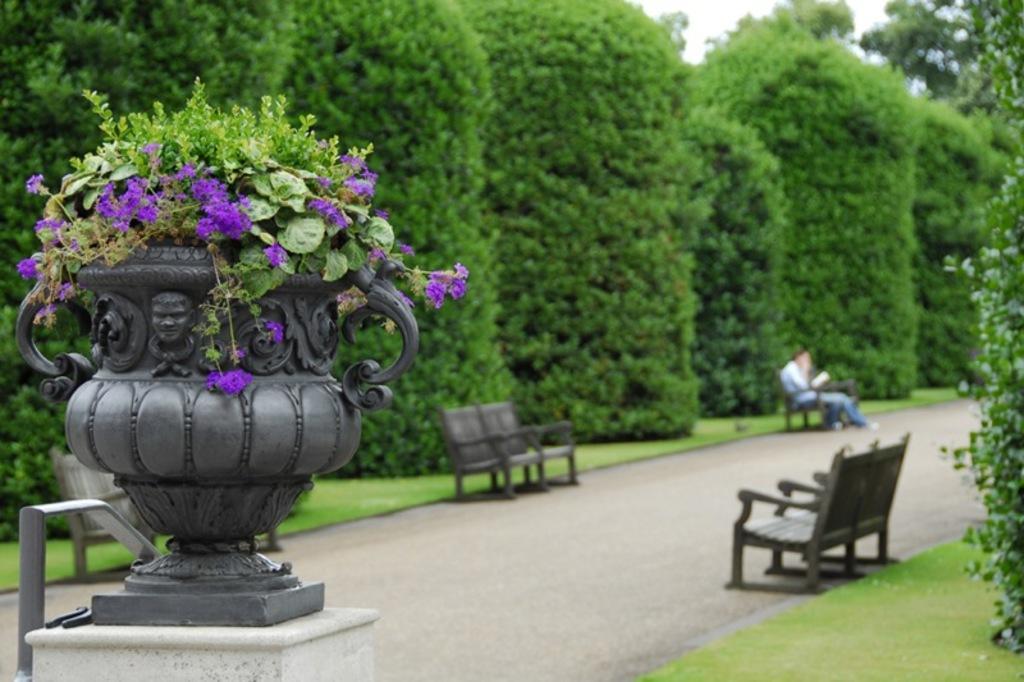How would you summarize this image in a sentence or two? On the background we can see trees. At the top there is a sky. Here on the road we can see benches. We can a man sitting on a bench and holding a book in his hand. In Front portion of the picture we can see a flower plant with pot. This is a grass. 